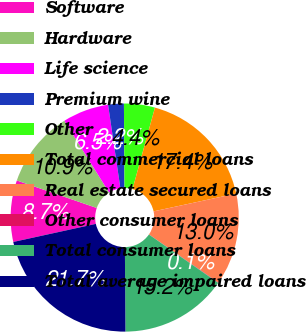Convert chart to OTSL. <chart><loc_0><loc_0><loc_500><loc_500><pie_chart><fcel>Software<fcel>Hardware<fcel>Life science<fcel>Premium wine<fcel>Other<fcel>Total commercial loans<fcel>Real estate secured loans<fcel>Other consumer loans<fcel>Total consumer loans<fcel>Total average impaired loans<nl><fcel>8.7%<fcel>10.86%<fcel>6.54%<fcel>2.22%<fcel>4.38%<fcel>17.35%<fcel>13.03%<fcel>0.05%<fcel>15.19%<fcel>21.67%<nl></chart> 